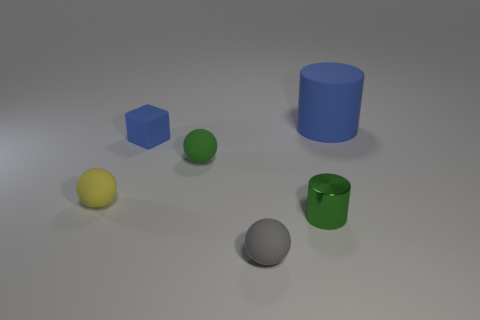Are these objects arranged in any particular order or pattern? The objects appear to be randomly placed, without a specific pattern. They are positioned at varying distances from each other, suggesting no intentional arrangement. 